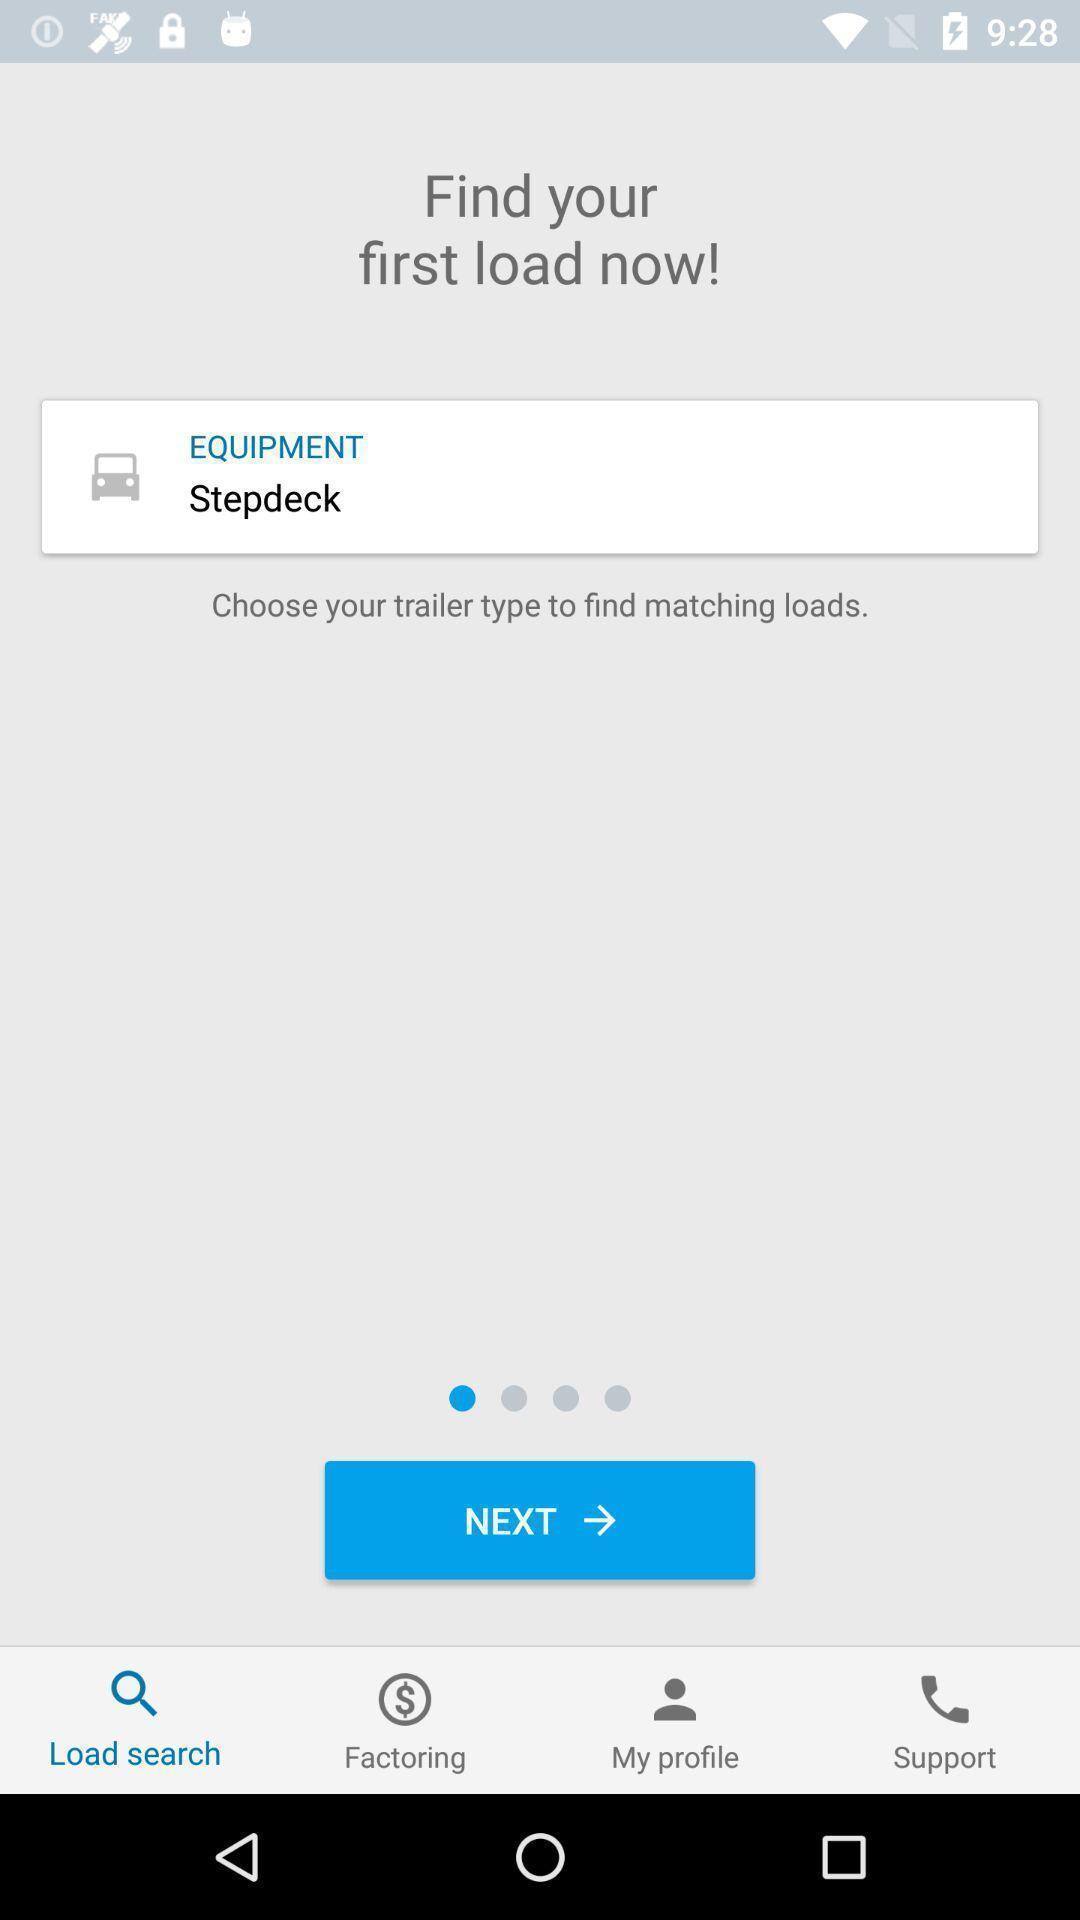Tell me what you see in this picture. Search page for an application. 